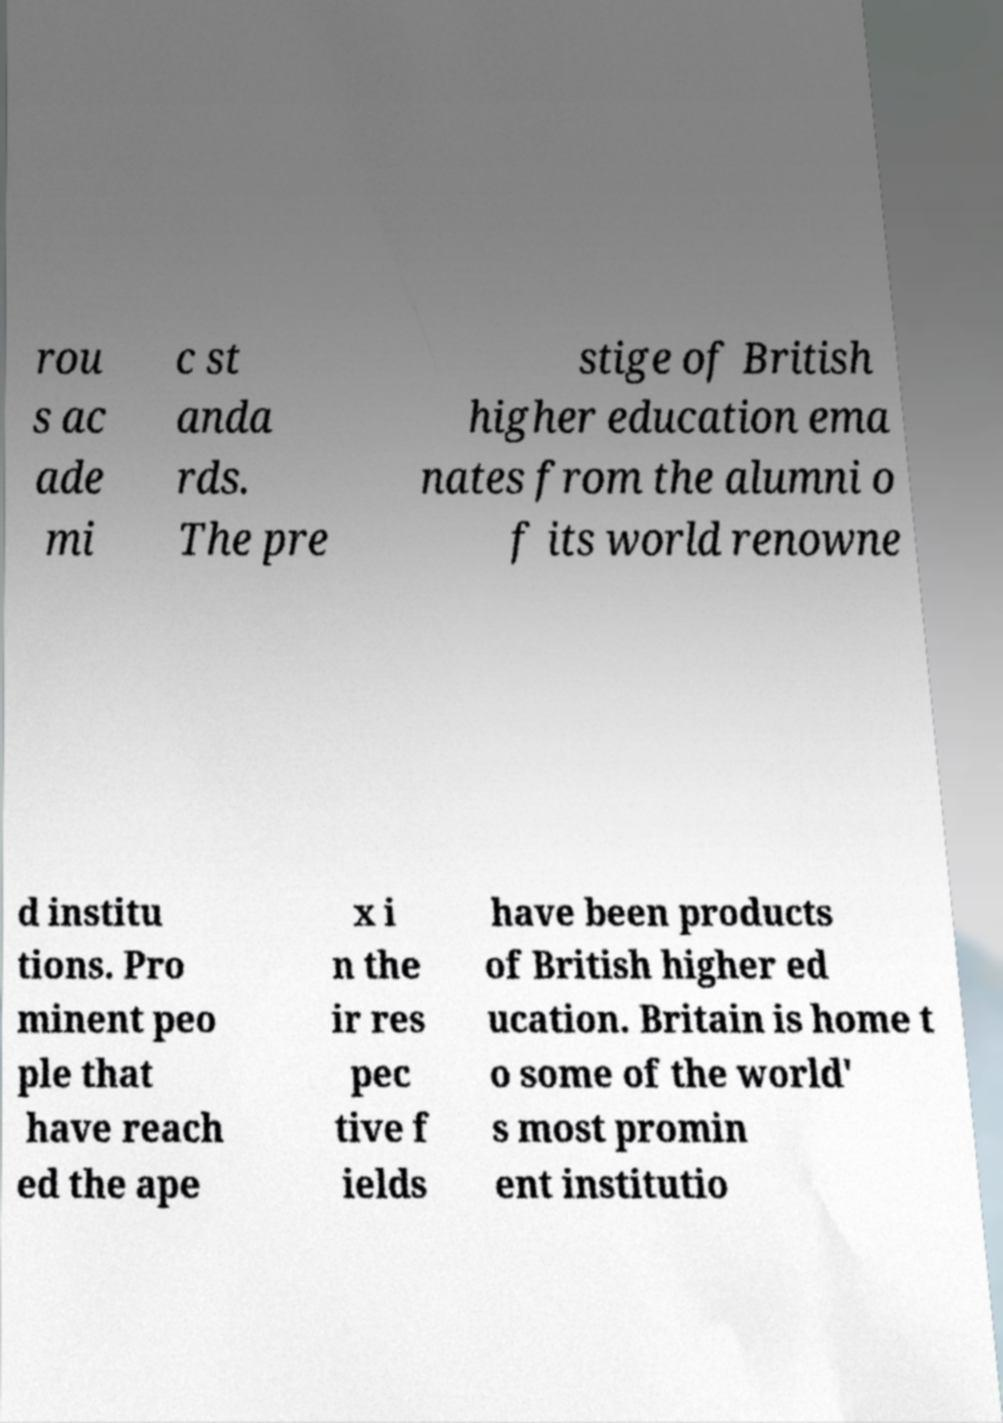Could you assist in decoding the text presented in this image and type it out clearly? rou s ac ade mi c st anda rds. The pre stige of British higher education ema nates from the alumni o f its world renowne d institu tions. Pro minent peo ple that have reach ed the ape x i n the ir res pec tive f ields have been products of British higher ed ucation. Britain is home t o some of the world' s most promin ent institutio 